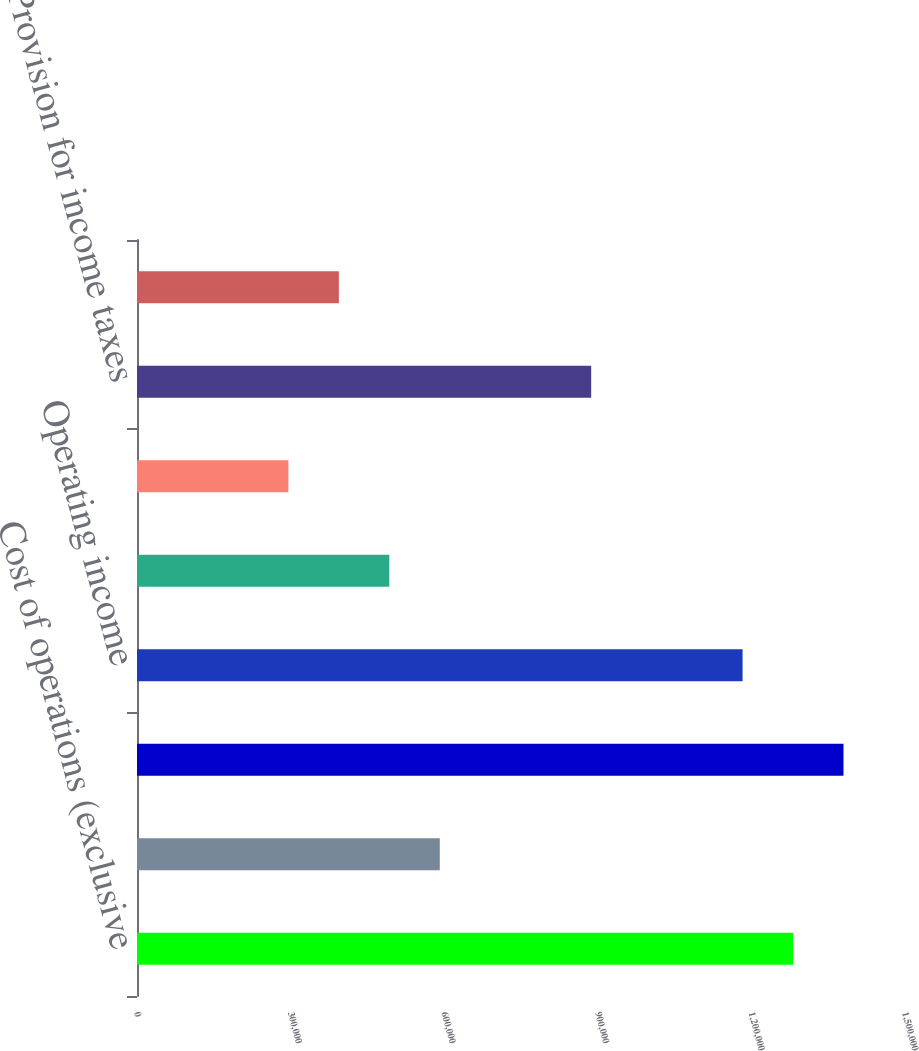<chart> <loc_0><loc_0><loc_500><loc_500><bar_chart><fcel>Cost of operations (exclusive<fcel>Depreciation and other<fcel>Total operating expenses<fcel>Operating income<fcel>Interest expense net<fcel>Income from continuing<fcel>Provision for income taxes<fcel>Loss from discontinued<nl><fcel>1.28132e+06<fcel>591378<fcel>1.37988e+06<fcel>1.18275e+06<fcel>492815<fcel>295690<fcel>887066<fcel>394253<nl></chart> 